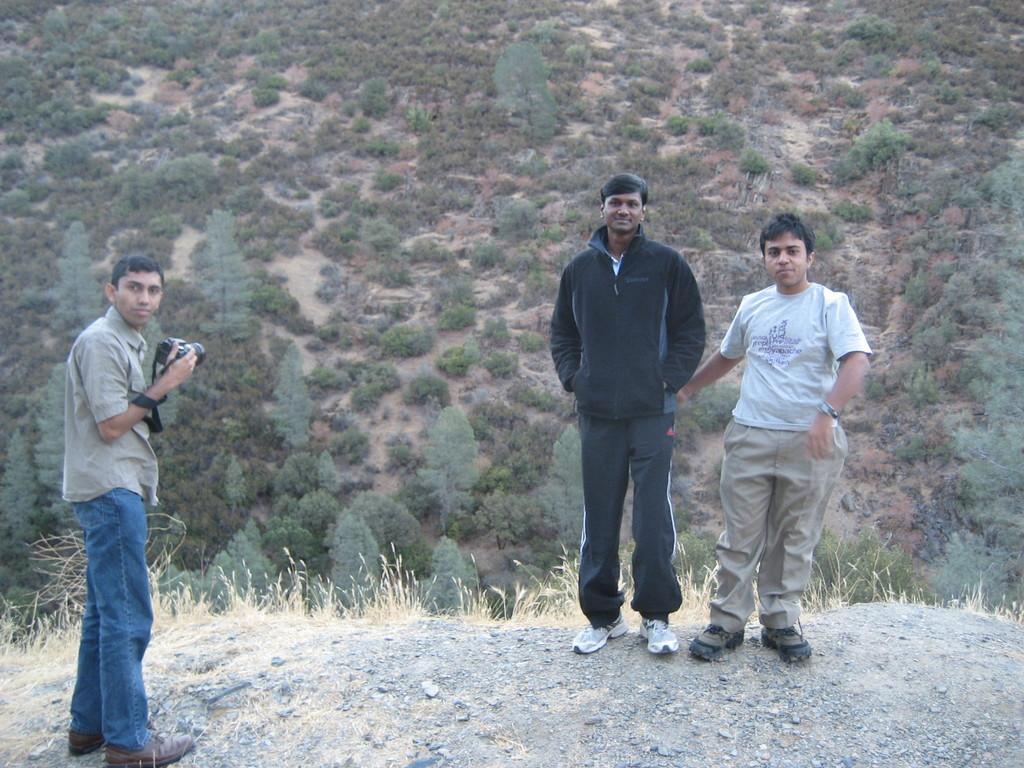Can you describe this image briefly? In the foreground of the picture towards right there are two men standing. On the left there is a man holding camera. In the foreground there are stones and dry grass. In the background there are shrubs and trees on the hill. 